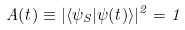Convert formula to latex. <formula><loc_0><loc_0><loc_500><loc_500>A ( t ) \equiv | \langle \psi _ { S } | \psi ( t ) \rangle | ^ { 2 } = 1</formula> 